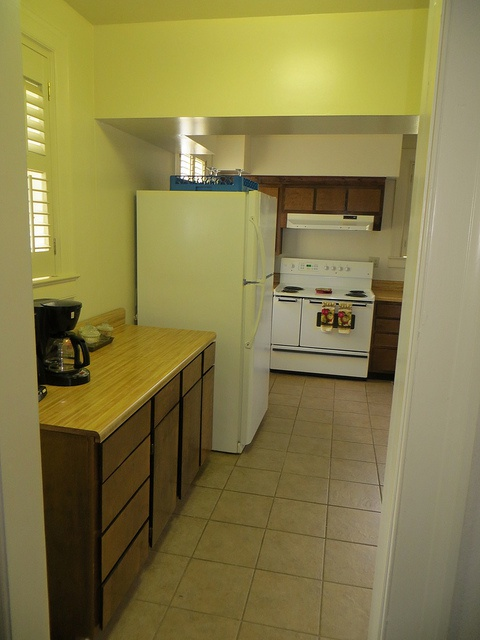Describe the objects in this image and their specific colors. I can see refrigerator in olive tones and oven in olive, gray, darkgray, and black tones in this image. 